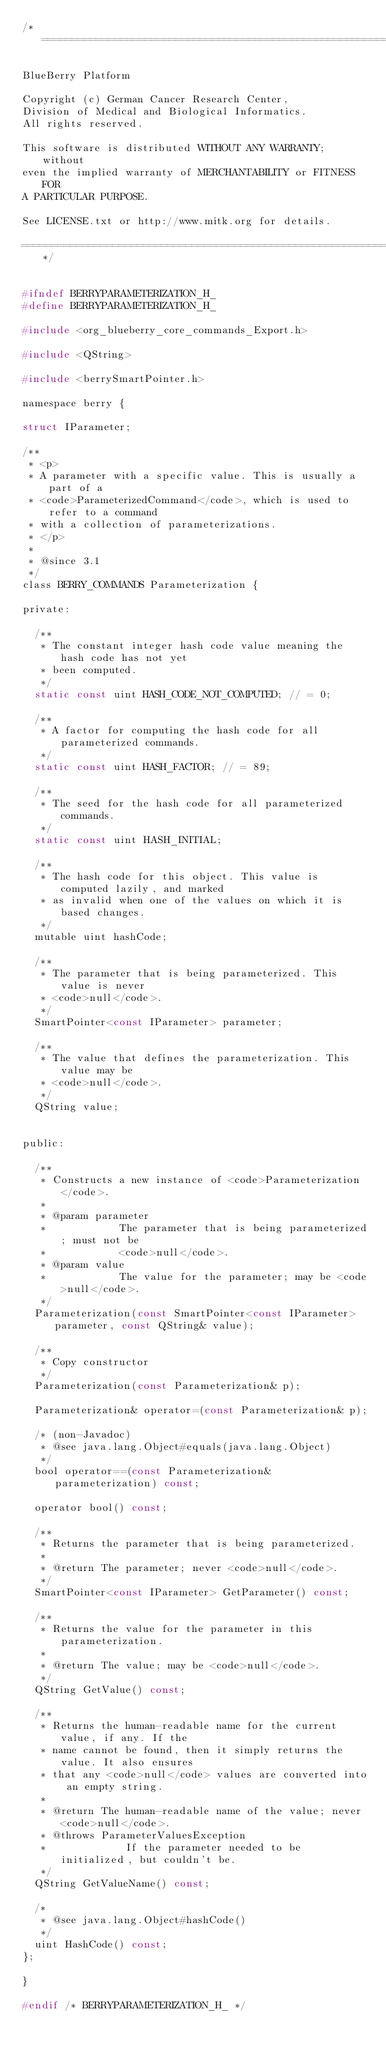Convert code to text. <code><loc_0><loc_0><loc_500><loc_500><_C_>/*===================================================================

BlueBerry Platform

Copyright (c) German Cancer Research Center,
Division of Medical and Biological Informatics.
All rights reserved.

This software is distributed WITHOUT ANY WARRANTY; without
even the implied warranty of MERCHANTABILITY or FITNESS FOR
A PARTICULAR PURPOSE.

See LICENSE.txt or http://www.mitk.org for details.

===================================================================*/


#ifndef BERRYPARAMETERIZATION_H_
#define BERRYPARAMETERIZATION_H_

#include <org_blueberry_core_commands_Export.h>

#include <QString>

#include <berrySmartPointer.h>

namespace berry {

struct IParameter;

/**
 * <p>
 * A parameter with a specific value. This is usually a part of a
 * <code>ParameterizedCommand</code>, which is used to refer to a command
 * with a collection of parameterizations.
 * </p>
 *
 * @since 3.1
 */
class BERRY_COMMANDS Parameterization {

private:

  /**
   * The constant integer hash code value meaning the hash code has not yet
   * been computed.
   */
  static const uint HASH_CODE_NOT_COMPUTED; // = 0;

  /**
   * A factor for computing the hash code for all parameterized commands.
   */
  static const uint HASH_FACTOR; // = 89;

  /**
   * The seed for the hash code for all parameterized commands.
   */
  static const uint HASH_INITIAL;

  /**
   * The hash code for this object. This value is computed lazily, and marked
   * as invalid when one of the values on which it is based changes.
   */
  mutable uint hashCode;

  /**
   * The parameter that is being parameterized. This value is never
   * <code>null</code>.
   */
  SmartPointer<const IParameter> parameter;

  /**
   * The value that defines the parameterization. This value may be
   * <code>null</code>.
   */
  QString value;


public:

  /**
   * Constructs a new instance of <code>Parameterization</code>.
   *
   * @param parameter
   *            The parameter that is being parameterized; must not be
   *            <code>null</code>.
   * @param value
   *            The value for the parameter; may be <code>null</code>.
   */
  Parameterization(const SmartPointer<const IParameter> parameter, const QString& value);

  /**
   * Copy constructor
   */
  Parameterization(const Parameterization& p);

  Parameterization& operator=(const Parameterization& p);

  /* (non-Javadoc)
   * @see java.lang.Object#equals(java.lang.Object)
   */
  bool operator==(const Parameterization& parameterization) const;

  operator bool() const;

  /**
   * Returns the parameter that is being parameterized.
   *
   * @return The parameter; never <code>null</code>.
   */
  SmartPointer<const IParameter> GetParameter() const;

  /**
   * Returns the value for the parameter in this parameterization.
   *
   * @return The value; may be <code>null</code>.
   */
  QString GetValue() const;

  /**
   * Returns the human-readable name for the current value, if any. If the
   * name cannot be found, then it simply returns the value. It also ensures
   * that any <code>null</code> values are converted into an empty string.
   *
   * @return The human-readable name of the value; never <code>null</code>.
   * @throws ParameterValuesException
   *             If the parameter needed to be initialized, but couldn't be.
   */
  QString GetValueName() const;

  /*
   * @see java.lang.Object#hashCode()
   */
  uint HashCode() const;
};

}

#endif /* BERRYPARAMETERIZATION_H_ */
</code> 